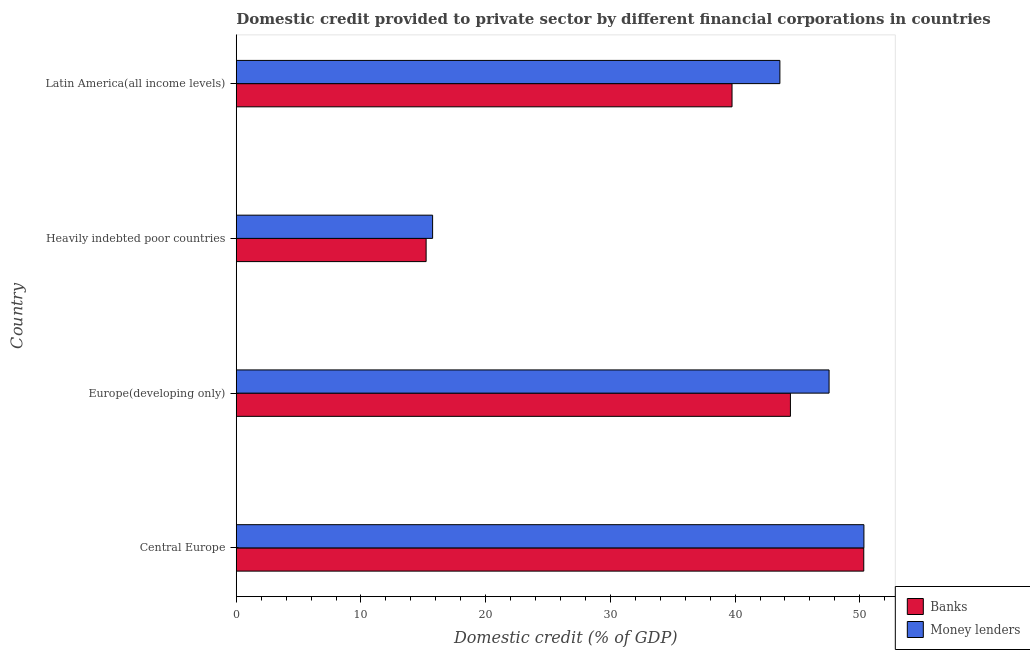How many different coloured bars are there?
Offer a terse response. 2. How many groups of bars are there?
Make the answer very short. 4. Are the number of bars per tick equal to the number of legend labels?
Provide a short and direct response. Yes. Are the number of bars on each tick of the Y-axis equal?
Keep it short and to the point. Yes. How many bars are there on the 2nd tick from the top?
Keep it short and to the point. 2. How many bars are there on the 4th tick from the bottom?
Offer a terse response. 2. What is the label of the 1st group of bars from the top?
Your response must be concise. Latin America(all income levels). In how many cases, is the number of bars for a given country not equal to the number of legend labels?
Provide a short and direct response. 0. What is the domestic credit provided by money lenders in Heavily indebted poor countries?
Your response must be concise. 15.75. Across all countries, what is the maximum domestic credit provided by banks?
Keep it short and to the point. 50.32. Across all countries, what is the minimum domestic credit provided by banks?
Ensure brevity in your answer.  15.23. In which country was the domestic credit provided by money lenders maximum?
Make the answer very short. Central Europe. In which country was the domestic credit provided by banks minimum?
Offer a very short reply. Heavily indebted poor countries. What is the total domestic credit provided by money lenders in the graph?
Provide a short and direct response. 157.21. What is the difference between the domestic credit provided by money lenders in Europe(developing only) and that in Heavily indebted poor countries?
Provide a succinct answer. 31.79. What is the difference between the domestic credit provided by money lenders in Central Europe and the domestic credit provided by banks in Heavily indebted poor countries?
Your response must be concise. 35.11. What is the average domestic credit provided by money lenders per country?
Provide a short and direct response. 39.3. What is the difference between the domestic credit provided by banks and domestic credit provided by money lenders in Central Europe?
Offer a terse response. -0.01. What is the ratio of the domestic credit provided by banks in Central Europe to that in Europe(developing only)?
Give a very brief answer. 1.13. What is the difference between the highest and the second highest domestic credit provided by money lenders?
Offer a very short reply. 2.79. What is the difference between the highest and the lowest domestic credit provided by banks?
Offer a very short reply. 35.09. What does the 1st bar from the top in Heavily indebted poor countries represents?
Offer a terse response. Money lenders. What does the 2nd bar from the bottom in Central Europe represents?
Keep it short and to the point. Money lenders. How many countries are there in the graph?
Ensure brevity in your answer.  4. Are the values on the major ticks of X-axis written in scientific E-notation?
Give a very brief answer. No. What is the title of the graph?
Offer a very short reply. Domestic credit provided to private sector by different financial corporations in countries. What is the label or title of the X-axis?
Offer a very short reply. Domestic credit (% of GDP). What is the Domestic credit (% of GDP) of Banks in Central Europe?
Offer a very short reply. 50.32. What is the Domestic credit (% of GDP) in Money lenders in Central Europe?
Provide a succinct answer. 50.33. What is the Domestic credit (% of GDP) in Banks in Europe(developing only)?
Provide a short and direct response. 44.44. What is the Domestic credit (% of GDP) in Money lenders in Europe(developing only)?
Give a very brief answer. 47.54. What is the Domestic credit (% of GDP) in Banks in Heavily indebted poor countries?
Give a very brief answer. 15.23. What is the Domestic credit (% of GDP) in Money lenders in Heavily indebted poor countries?
Offer a terse response. 15.75. What is the Domestic credit (% of GDP) in Banks in Latin America(all income levels)?
Provide a succinct answer. 39.76. What is the Domestic credit (% of GDP) of Money lenders in Latin America(all income levels)?
Ensure brevity in your answer.  43.59. Across all countries, what is the maximum Domestic credit (% of GDP) of Banks?
Your answer should be very brief. 50.32. Across all countries, what is the maximum Domestic credit (% of GDP) of Money lenders?
Keep it short and to the point. 50.33. Across all countries, what is the minimum Domestic credit (% of GDP) in Banks?
Offer a very short reply. 15.23. Across all countries, what is the minimum Domestic credit (% of GDP) in Money lenders?
Keep it short and to the point. 15.75. What is the total Domestic credit (% of GDP) in Banks in the graph?
Offer a terse response. 149.74. What is the total Domestic credit (% of GDP) of Money lenders in the graph?
Offer a very short reply. 157.21. What is the difference between the Domestic credit (% of GDP) of Banks in Central Europe and that in Europe(developing only)?
Provide a succinct answer. 5.88. What is the difference between the Domestic credit (% of GDP) of Money lenders in Central Europe and that in Europe(developing only)?
Provide a short and direct response. 2.79. What is the difference between the Domestic credit (% of GDP) of Banks in Central Europe and that in Heavily indebted poor countries?
Offer a terse response. 35.09. What is the difference between the Domestic credit (% of GDP) of Money lenders in Central Europe and that in Heavily indebted poor countries?
Provide a succinct answer. 34.59. What is the difference between the Domestic credit (% of GDP) of Banks in Central Europe and that in Latin America(all income levels)?
Your answer should be compact. 10.56. What is the difference between the Domestic credit (% of GDP) of Money lenders in Central Europe and that in Latin America(all income levels)?
Your answer should be very brief. 6.74. What is the difference between the Domestic credit (% of GDP) in Banks in Europe(developing only) and that in Heavily indebted poor countries?
Your response must be concise. 29.21. What is the difference between the Domestic credit (% of GDP) of Money lenders in Europe(developing only) and that in Heavily indebted poor countries?
Your response must be concise. 31.79. What is the difference between the Domestic credit (% of GDP) of Banks in Europe(developing only) and that in Latin America(all income levels)?
Provide a short and direct response. 4.68. What is the difference between the Domestic credit (% of GDP) of Money lenders in Europe(developing only) and that in Latin America(all income levels)?
Offer a very short reply. 3.95. What is the difference between the Domestic credit (% of GDP) of Banks in Heavily indebted poor countries and that in Latin America(all income levels)?
Provide a short and direct response. -24.53. What is the difference between the Domestic credit (% of GDP) of Money lenders in Heavily indebted poor countries and that in Latin America(all income levels)?
Your answer should be compact. -27.85. What is the difference between the Domestic credit (% of GDP) of Banks in Central Europe and the Domestic credit (% of GDP) of Money lenders in Europe(developing only)?
Your answer should be compact. 2.78. What is the difference between the Domestic credit (% of GDP) in Banks in Central Europe and the Domestic credit (% of GDP) in Money lenders in Heavily indebted poor countries?
Offer a terse response. 34.57. What is the difference between the Domestic credit (% of GDP) in Banks in Central Europe and the Domestic credit (% of GDP) in Money lenders in Latin America(all income levels)?
Provide a succinct answer. 6.73. What is the difference between the Domestic credit (% of GDP) in Banks in Europe(developing only) and the Domestic credit (% of GDP) in Money lenders in Heavily indebted poor countries?
Keep it short and to the point. 28.69. What is the difference between the Domestic credit (% of GDP) of Banks in Europe(developing only) and the Domestic credit (% of GDP) of Money lenders in Latin America(all income levels)?
Provide a short and direct response. 0.85. What is the difference between the Domestic credit (% of GDP) of Banks in Heavily indebted poor countries and the Domestic credit (% of GDP) of Money lenders in Latin America(all income levels)?
Ensure brevity in your answer.  -28.37. What is the average Domestic credit (% of GDP) of Banks per country?
Offer a very short reply. 37.43. What is the average Domestic credit (% of GDP) of Money lenders per country?
Your answer should be compact. 39.3. What is the difference between the Domestic credit (% of GDP) in Banks and Domestic credit (% of GDP) in Money lenders in Central Europe?
Offer a terse response. -0.01. What is the difference between the Domestic credit (% of GDP) of Banks and Domestic credit (% of GDP) of Money lenders in Europe(developing only)?
Provide a short and direct response. -3.1. What is the difference between the Domestic credit (% of GDP) of Banks and Domestic credit (% of GDP) of Money lenders in Heavily indebted poor countries?
Offer a very short reply. -0.52. What is the difference between the Domestic credit (% of GDP) in Banks and Domestic credit (% of GDP) in Money lenders in Latin America(all income levels)?
Your response must be concise. -3.84. What is the ratio of the Domestic credit (% of GDP) of Banks in Central Europe to that in Europe(developing only)?
Your answer should be compact. 1.13. What is the ratio of the Domestic credit (% of GDP) of Money lenders in Central Europe to that in Europe(developing only)?
Give a very brief answer. 1.06. What is the ratio of the Domestic credit (% of GDP) of Banks in Central Europe to that in Heavily indebted poor countries?
Offer a terse response. 3.31. What is the ratio of the Domestic credit (% of GDP) of Money lenders in Central Europe to that in Heavily indebted poor countries?
Provide a short and direct response. 3.2. What is the ratio of the Domestic credit (% of GDP) in Banks in Central Europe to that in Latin America(all income levels)?
Ensure brevity in your answer.  1.27. What is the ratio of the Domestic credit (% of GDP) in Money lenders in Central Europe to that in Latin America(all income levels)?
Your answer should be compact. 1.15. What is the ratio of the Domestic credit (% of GDP) of Banks in Europe(developing only) to that in Heavily indebted poor countries?
Make the answer very short. 2.92. What is the ratio of the Domestic credit (% of GDP) in Money lenders in Europe(developing only) to that in Heavily indebted poor countries?
Give a very brief answer. 3.02. What is the ratio of the Domestic credit (% of GDP) of Banks in Europe(developing only) to that in Latin America(all income levels)?
Give a very brief answer. 1.12. What is the ratio of the Domestic credit (% of GDP) of Money lenders in Europe(developing only) to that in Latin America(all income levels)?
Give a very brief answer. 1.09. What is the ratio of the Domestic credit (% of GDP) in Banks in Heavily indebted poor countries to that in Latin America(all income levels)?
Ensure brevity in your answer.  0.38. What is the ratio of the Domestic credit (% of GDP) of Money lenders in Heavily indebted poor countries to that in Latin America(all income levels)?
Provide a short and direct response. 0.36. What is the difference between the highest and the second highest Domestic credit (% of GDP) of Banks?
Your response must be concise. 5.88. What is the difference between the highest and the second highest Domestic credit (% of GDP) of Money lenders?
Give a very brief answer. 2.79. What is the difference between the highest and the lowest Domestic credit (% of GDP) of Banks?
Provide a succinct answer. 35.09. What is the difference between the highest and the lowest Domestic credit (% of GDP) in Money lenders?
Your answer should be very brief. 34.59. 